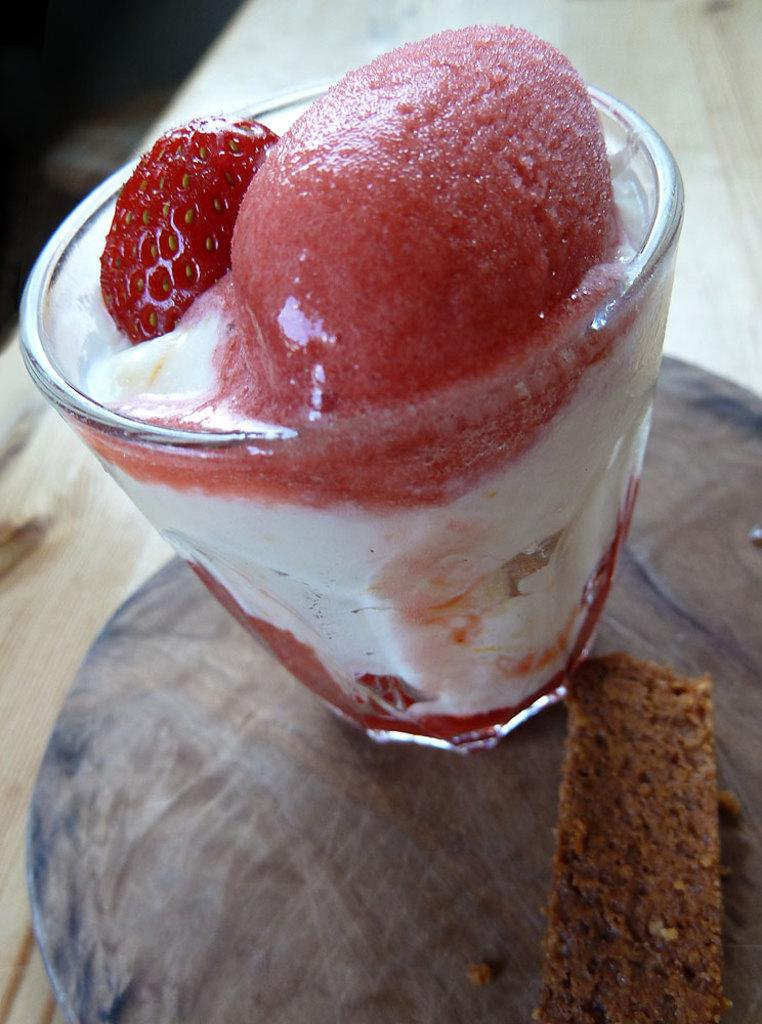What is inside the glass that is visible in the image? The glass contains a desert in the image. Where is the glass located? The glass is placed on a table in the image. What type of bird can be seen flying over the desert in the image? There are no birds visible in the image; it only shows a glass containing a desert on a table. 